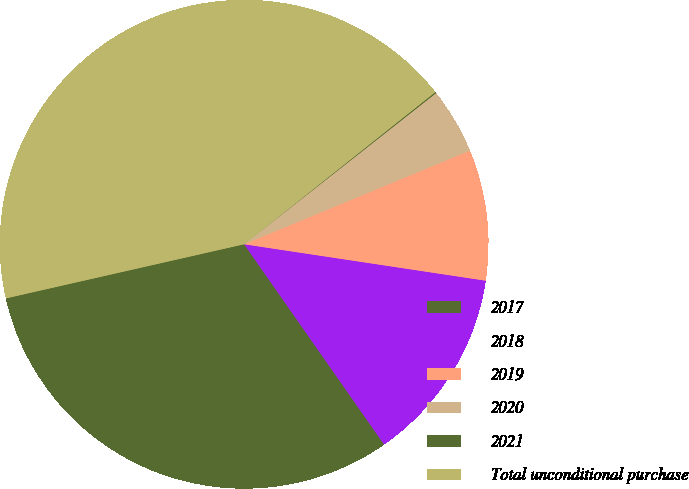Convert chart. <chart><loc_0><loc_0><loc_500><loc_500><pie_chart><fcel>2017<fcel>2018<fcel>2019<fcel>2020<fcel>2021<fcel>Total unconditional purchase<nl><fcel>31.15%<fcel>12.91%<fcel>8.64%<fcel>4.36%<fcel>0.08%<fcel>42.86%<nl></chart> 